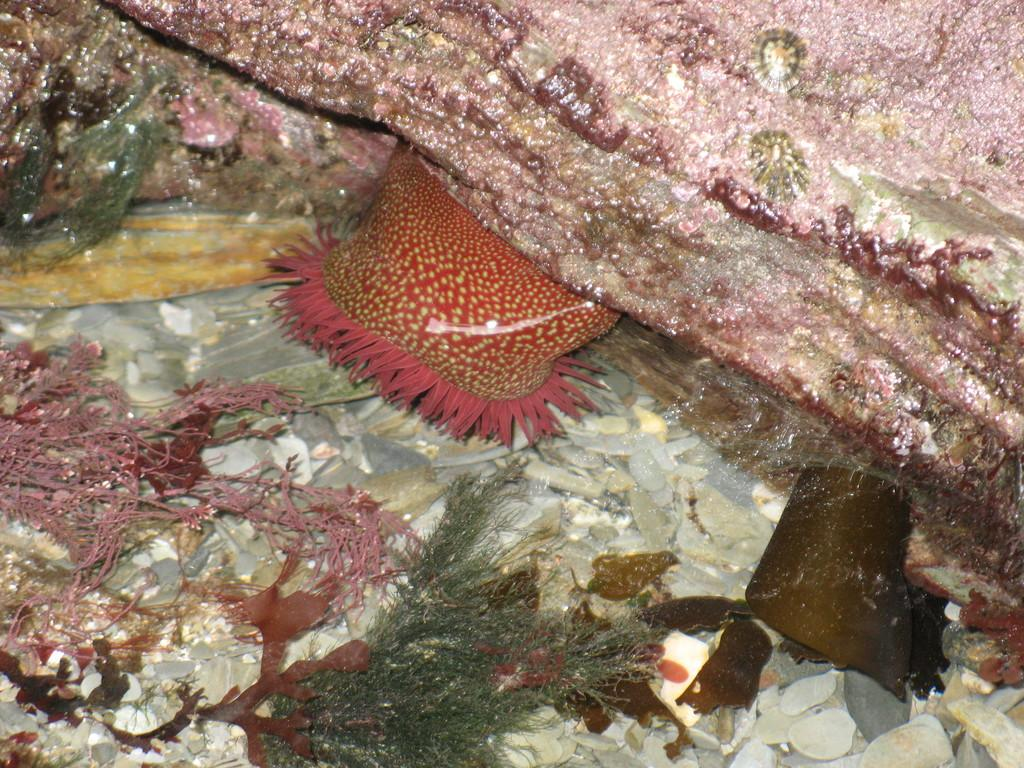What type of animal can be seen in the image? There is a sea creature in the image. Where is the sea creature located in the image? The sea creature is under a rock. What other objects can be seen in the image? There are stones and aqua plants present in the image. What type of cord is connected to the brain of the sea creature in the image? There is no cord or brain present in the image; it features a sea creature under a rock with stones and aqua plants. 